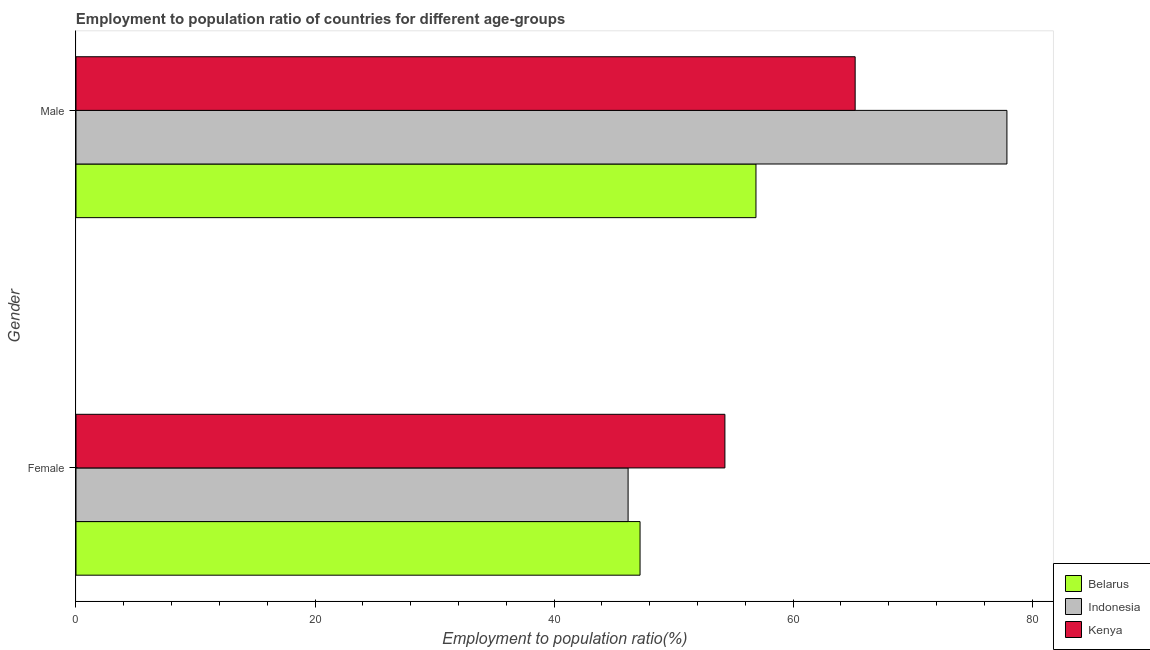How many different coloured bars are there?
Provide a short and direct response. 3. How many groups of bars are there?
Offer a terse response. 2. Are the number of bars on each tick of the Y-axis equal?
Offer a terse response. Yes. How many bars are there on the 1st tick from the top?
Offer a very short reply. 3. What is the label of the 2nd group of bars from the top?
Your response must be concise. Female. What is the employment to population ratio(female) in Belarus?
Your response must be concise. 47.2. Across all countries, what is the maximum employment to population ratio(male)?
Make the answer very short. 77.9. Across all countries, what is the minimum employment to population ratio(male)?
Keep it short and to the point. 56.9. In which country was the employment to population ratio(female) maximum?
Give a very brief answer. Kenya. What is the total employment to population ratio(female) in the graph?
Provide a short and direct response. 147.7. What is the difference between the employment to population ratio(female) in Kenya and that in Indonesia?
Provide a short and direct response. 8.1. What is the difference between the employment to population ratio(female) in Kenya and the employment to population ratio(male) in Indonesia?
Your answer should be very brief. -23.6. What is the average employment to population ratio(male) per country?
Your answer should be compact. 66.67. What is the difference between the employment to population ratio(female) and employment to population ratio(male) in Indonesia?
Your answer should be compact. -31.7. What is the ratio of the employment to population ratio(female) in Indonesia to that in Kenya?
Your answer should be compact. 0.85. Is the employment to population ratio(female) in Indonesia less than that in Kenya?
Offer a terse response. Yes. What does the 3rd bar from the top in Male represents?
Provide a succinct answer. Belarus. What does the 1st bar from the bottom in Male represents?
Offer a terse response. Belarus. Are all the bars in the graph horizontal?
Provide a succinct answer. Yes. What is the difference between two consecutive major ticks on the X-axis?
Keep it short and to the point. 20. Are the values on the major ticks of X-axis written in scientific E-notation?
Offer a very short reply. No. Does the graph contain grids?
Your answer should be very brief. No. How many legend labels are there?
Provide a succinct answer. 3. What is the title of the graph?
Ensure brevity in your answer.  Employment to population ratio of countries for different age-groups. Does "Malta" appear as one of the legend labels in the graph?
Keep it short and to the point. No. What is the label or title of the Y-axis?
Your answer should be compact. Gender. What is the Employment to population ratio(%) in Belarus in Female?
Provide a short and direct response. 47.2. What is the Employment to population ratio(%) in Indonesia in Female?
Offer a terse response. 46.2. What is the Employment to population ratio(%) of Kenya in Female?
Give a very brief answer. 54.3. What is the Employment to population ratio(%) of Belarus in Male?
Your response must be concise. 56.9. What is the Employment to population ratio(%) in Indonesia in Male?
Give a very brief answer. 77.9. What is the Employment to population ratio(%) in Kenya in Male?
Give a very brief answer. 65.2. Across all Gender, what is the maximum Employment to population ratio(%) in Belarus?
Make the answer very short. 56.9. Across all Gender, what is the maximum Employment to population ratio(%) of Indonesia?
Ensure brevity in your answer.  77.9. Across all Gender, what is the maximum Employment to population ratio(%) in Kenya?
Offer a terse response. 65.2. Across all Gender, what is the minimum Employment to population ratio(%) in Belarus?
Your answer should be very brief. 47.2. Across all Gender, what is the minimum Employment to population ratio(%) in Indonesia?
Provide a short and direct response. 46.2. Across all Gender, what is the minimum Employment to population ratio(%) of Kenya?
Offer a very short reply. 54.3. What is the total Employment to population ratio(%) in Belarus in the graph?
Your answer should be very brief. 104.1. What is the total Employment to population ratio(%) of Indonesia in the graph?
Give a very brief answer. 124.1. What is the total Employment to population ratio(%) of Kenya in the graph?
Your answer should be compact. 119.5. What is the difference between the Employment to population ratio(%) in Indonesia in Female and that in Male?
Your response must be concise. -31.7. What is the difference between the Employment to population ratio(%) of Belarus in Female and the Employment to population ratio(%) of Indonesia in Male?
Ensure brevity in your answer.  -30.7. What is the difference between the Employment to population ratio(%) of Belarus in Female and the Employment to population ratio(%) of Kenya in Male?
Provide a succinct answer. -18. What is the average Employment to population ratio(%) of Belarus per Gender?
Provide a short and direct response. 52.05. What is the average Employment to population ratio(%) in Indonesia per Gender?
Ensure brevity in your answer.  62.05. What is the average Employment to population ratio(%) of Kenya per Gender?
Your response must be concise. 59.75. What is the difference between the Employment to population ratio(%) of Indonesia and Employment to population ratio(%) of Kenya in Female?
Offer a terse response. -8.1. What is the difference between the Employment to population ratio(%) in Indonesia and Employment to population ratio(%) in Kenya in Male?
Provide a short and direct response. 12.7. What is the ratio of the Employment to population ratio(%) of Belarus in Female to that in Male?
Your response must be concise. 0.83. What is the ratio of the Employment to population ratio(%) in Indonesia in Female to that in Male?
Provide a succinct answer. 0.59. What is the ratio of the Employment to population ratio(%) of Kenya in Female to that in Male?
Your answer should be compact. 0.83. What is the difference between the highest and the second highest Employment to population ratio(%) in Indonesia?
Provide a succinct answer. 31.7. What is the difference between the highest and the lowest Employment to population ratio(%) in Indonesia?
Provide a short and direct response. 31.7. What is the difference between the highest and the lowest Employment to population ratio(%) in Kenya?
Provide a short and direct response. 10.9. 